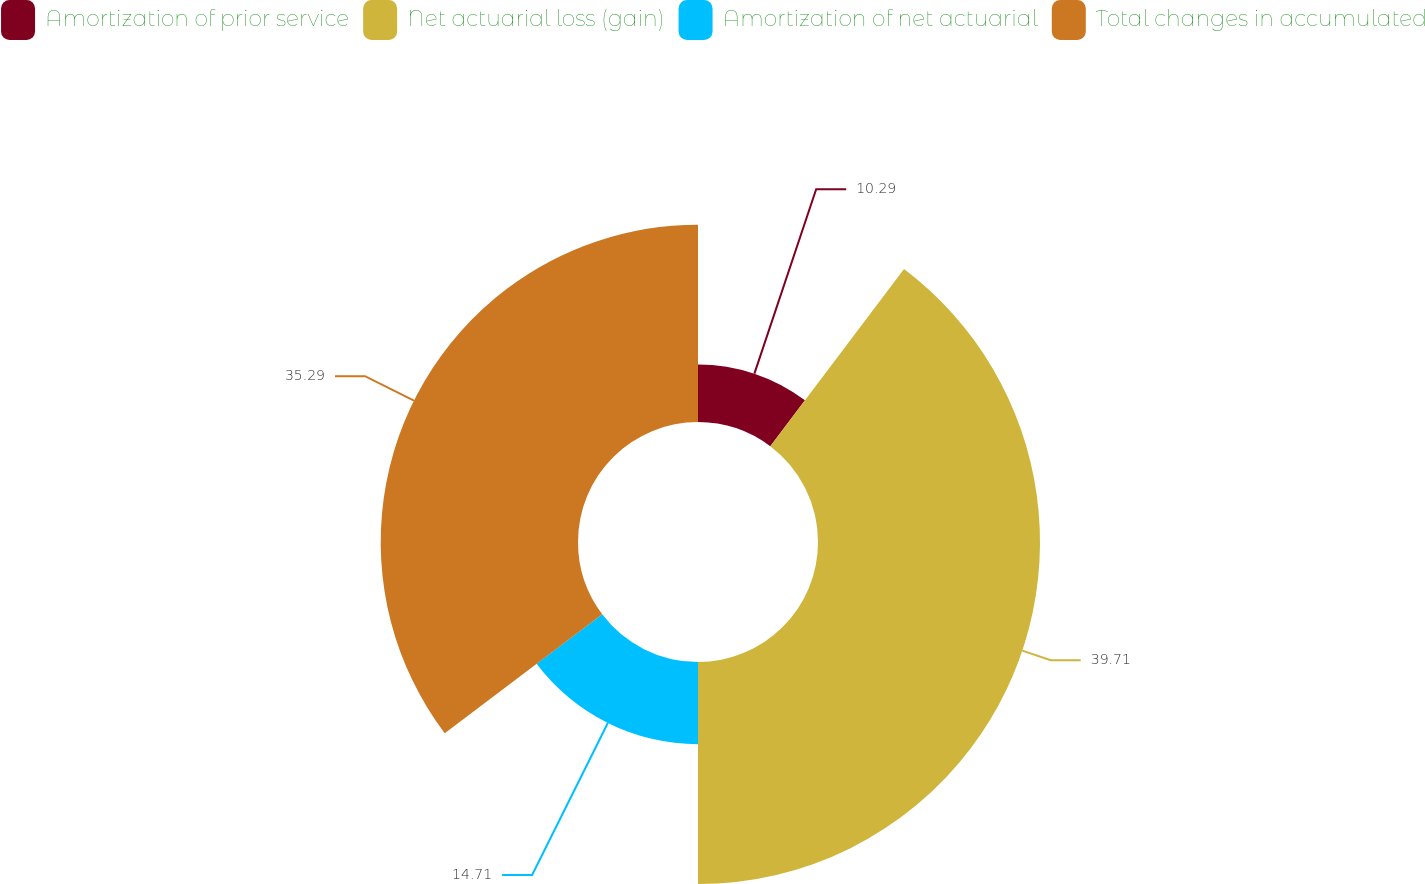Convert chart. <chart><loc_0><loc_0><loc_500><loc_500><pie_chart><fcel>Amortization of prior service<fcel>Net actuarial loss (gain)<fcel>Amortization of net actuarial<fcel>Total changes in accumulated<nl><fcel>10.29%<fcel>39.71%<fcel>14.71%<fcel>35.29%<nl></chart> 